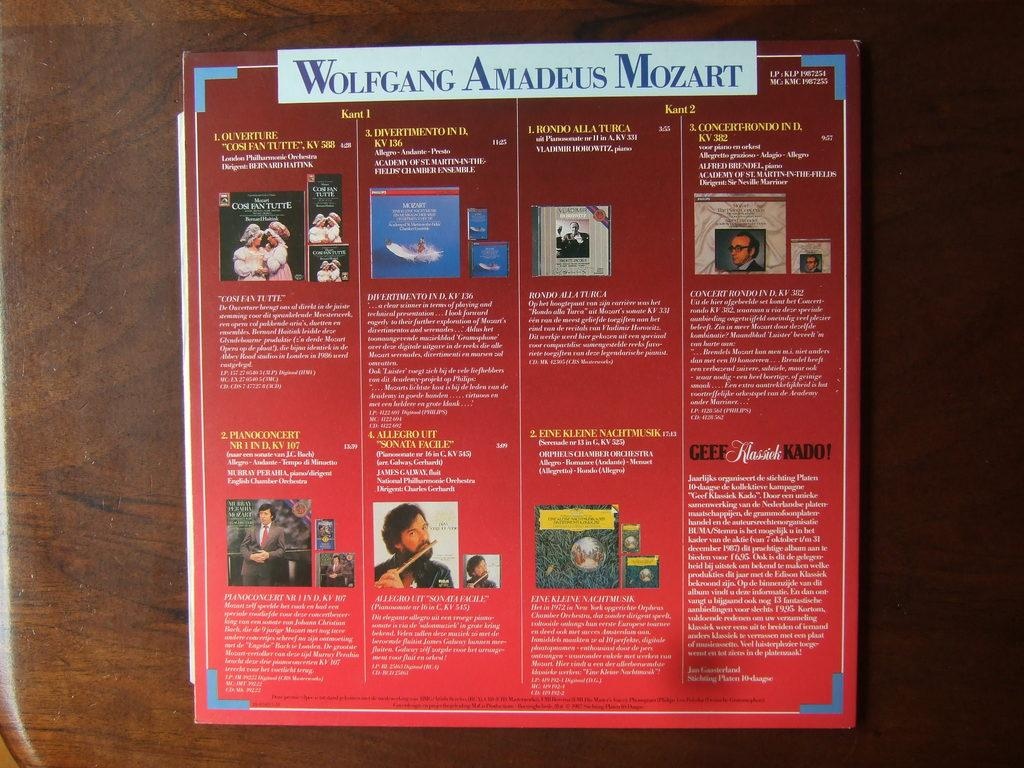<image>
Describe the image concisely. an item that has Wolfgang Amadeus Mozart at the top 